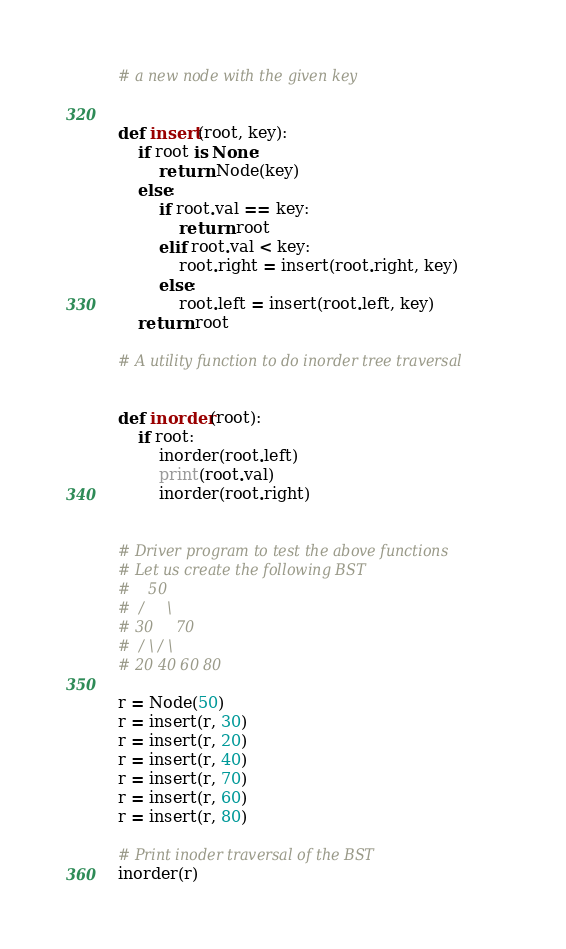<code> <loc_0><loc_0><loc_500><loc_500><_Python_># a new node with the given key


def insert(root, key):
    if root is None:
        return Node(key)
    else:
        if root.val == key:
            return root
        elif root.val < key:
            root.right = insert(root.right, key)
        else:
            root.left = insert(root.left, key)
    return root

# A utility function to do inorder tree traversal


def inorder(root):
    if root:
        inorder(root.left)
        print(root.val)
        inorder(root.right)


# Driver program to test the above functions
# Let us create the following BST
#    50
#  /     \
# 30     70
#  / \ / \
# 20 40 60 80

r = Node(50)
r = insert(r, 30)
r = insert(r, 20)
r = insert(r, 40)
r = insert(r, 70)
r = insert(r, 60)
r = insert(r, 80)

# Print inoder traversal of the BST
inorder(r)
</code> 